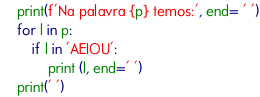<code> <loc_0><loc_0><loc_500><loc_500><_Python_>    print(f'Na palavra {p} temos:', end= ' ')
    for l in p:
        if l in 'AEIOU':
            print (l, end=' ')
    print(' ')

</code> 